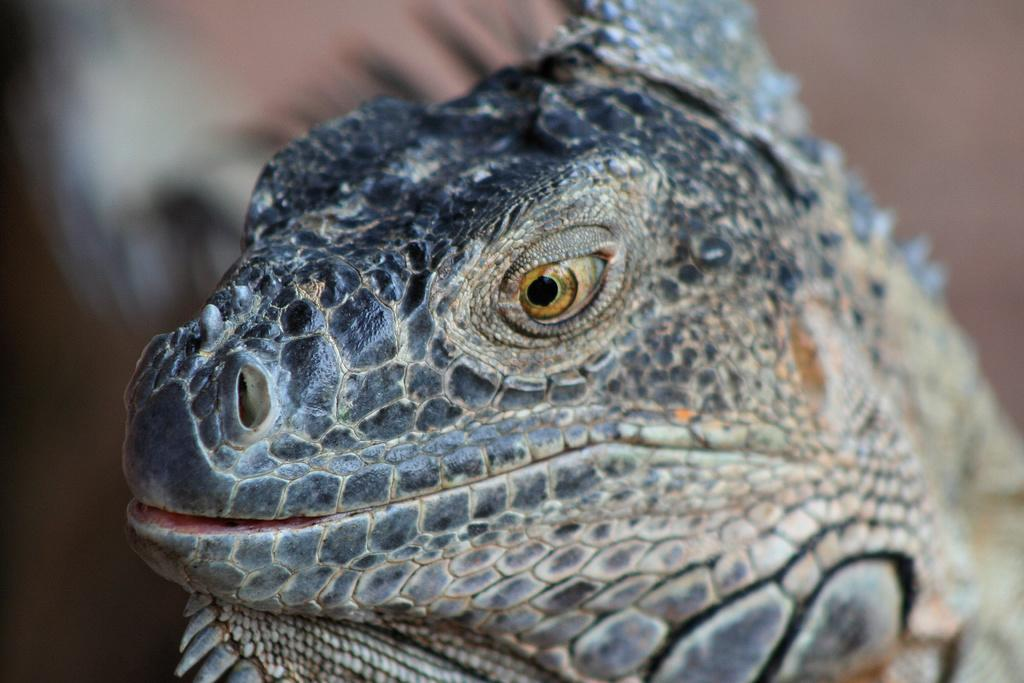What type of animal is in the image? There is a reptile in the image. Where is the reptile located in the image? The reptile is in the center of the image. What color is the reptile in the image? The reptile is black and white in color. What type of flowers are growing in the prison depicted in the image? There is no prison or flowers present in the image; it features a reptile that is black and white in color. 